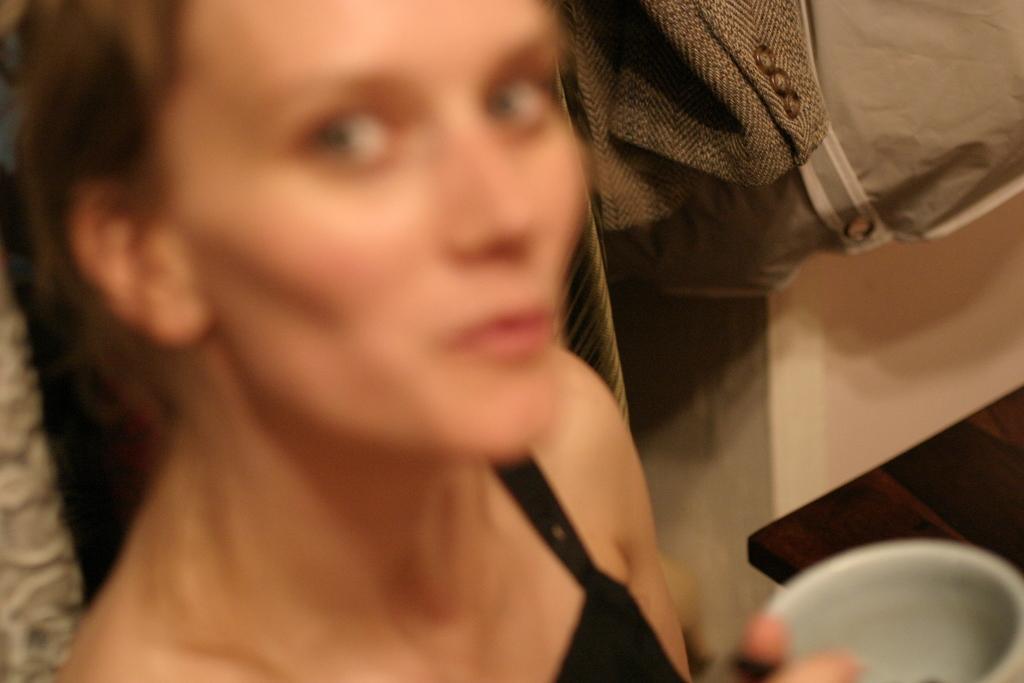In one or two sentences, can you explain what this image depicts? This image was slightly blurred. There is a woman wearing a black dress and holding a cup besides her there is a table. 